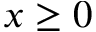<formula> <loc_0><loc_0><loc_500><loc_500>x \geq 0</formula> 